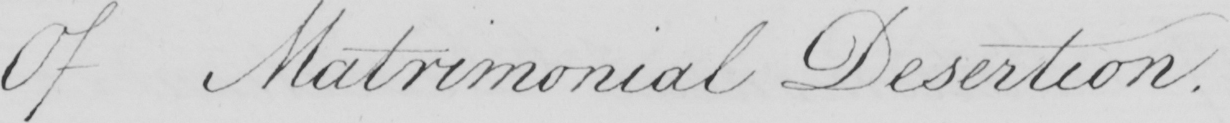Transcribe the text shown in this historical manuscript line. Of Matrimonial Desertion . 